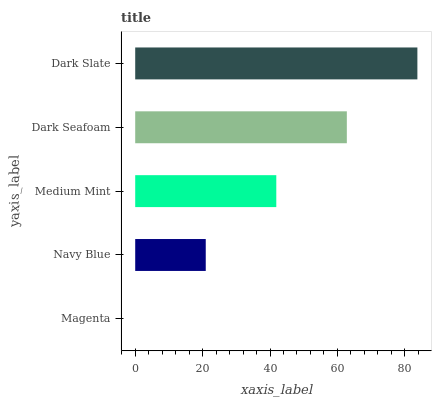Is Magenta the minimum?
Answer yes or no. Yes. Is Dark Slate the maximum?
Answer yes or no. Yes. Is Navy Blue the minimum?
Answer yes or no. No. Is Navy Blue the maximum?
Answer yes or no. No. Is Navy Blue greater than Magenta?
Answer yes or no. Yes. Is Magenta less than Navy Blue?
Answer yes or no. Yes. Is Magenta greater than Navy Blue?
Answer yes or no. No. Is Navy Blue less than Magenta?
Answer yes or no. No. Is Medium Mint the high median?
Answer yes or no. Yes. Is Medium Mint the low median?
Answer yes or no. Yes. Is Dark Slate the high median?
Answer yes or no. No. Is Magenta the low median?
Answer yes or no. No. 